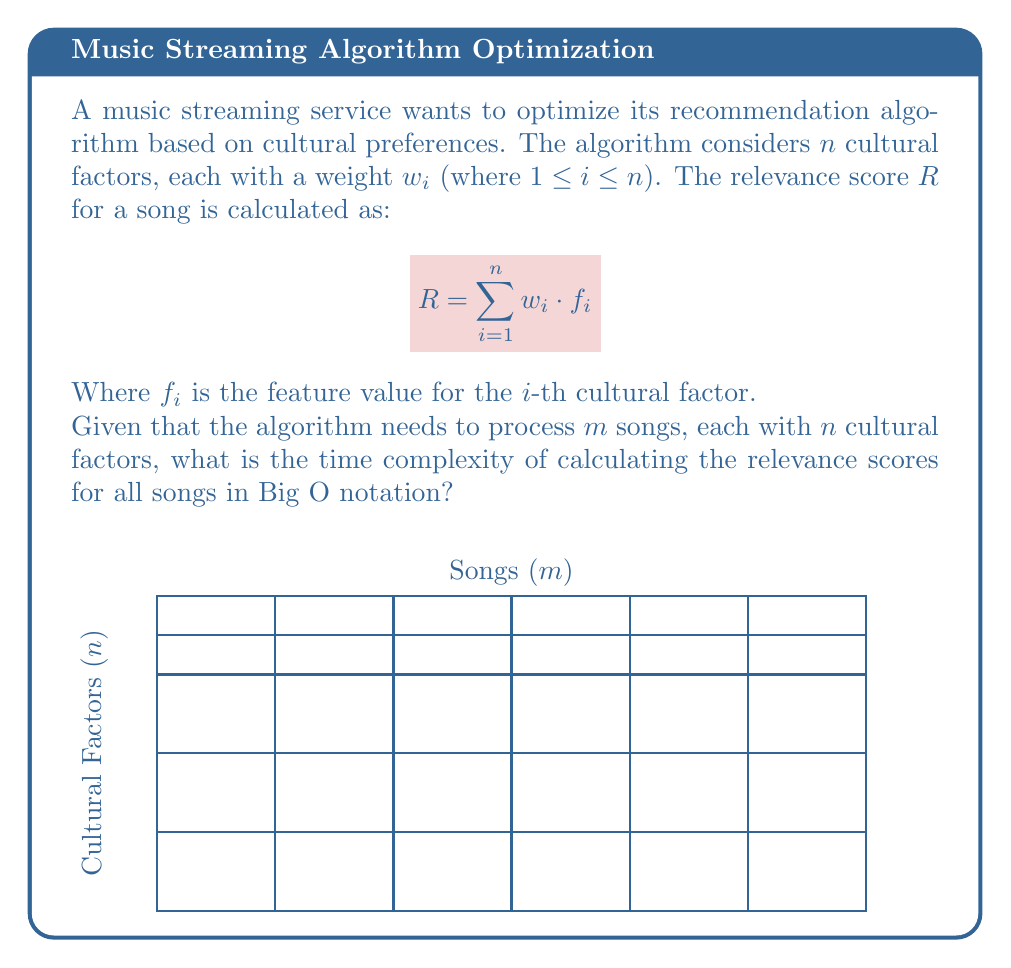Solve this math problem. Let's break down the problem step-by-step:

1) For each song, we need to calculate the relevance score $R$.

2) To calculate $R$, we perform the following operations for each cultural factor:
   - Multiplication: $w_i \cdot f_i$
   - Addition: Adding this product to the running sum

3) There are $n$ cultural factors, so for each song, we perform:
   - $n$ multiplications
   - $n$ additions

4) The total number of operations for one song is $2n$.

5) We need to repeat this process for all $m$ songs.

6) Therefore, the total number of operations is $m \cdot 2n = 2mn$.

7) In Big O notation, we drop constant factors. So, $2mn$ becomes $O(mn)$.

8) This represents a nested loop structure: an outer loop iterating over $m$ songs, and an inner loop iterating over $n$ cultural factors for each song.

From a cultural studies perspective, this algorithm allows for a nuanced approach to music recommendation, considering multiple cultural factors that may influence musical preferences across different genres and subcultures.
Answer: $O(mn)$ 